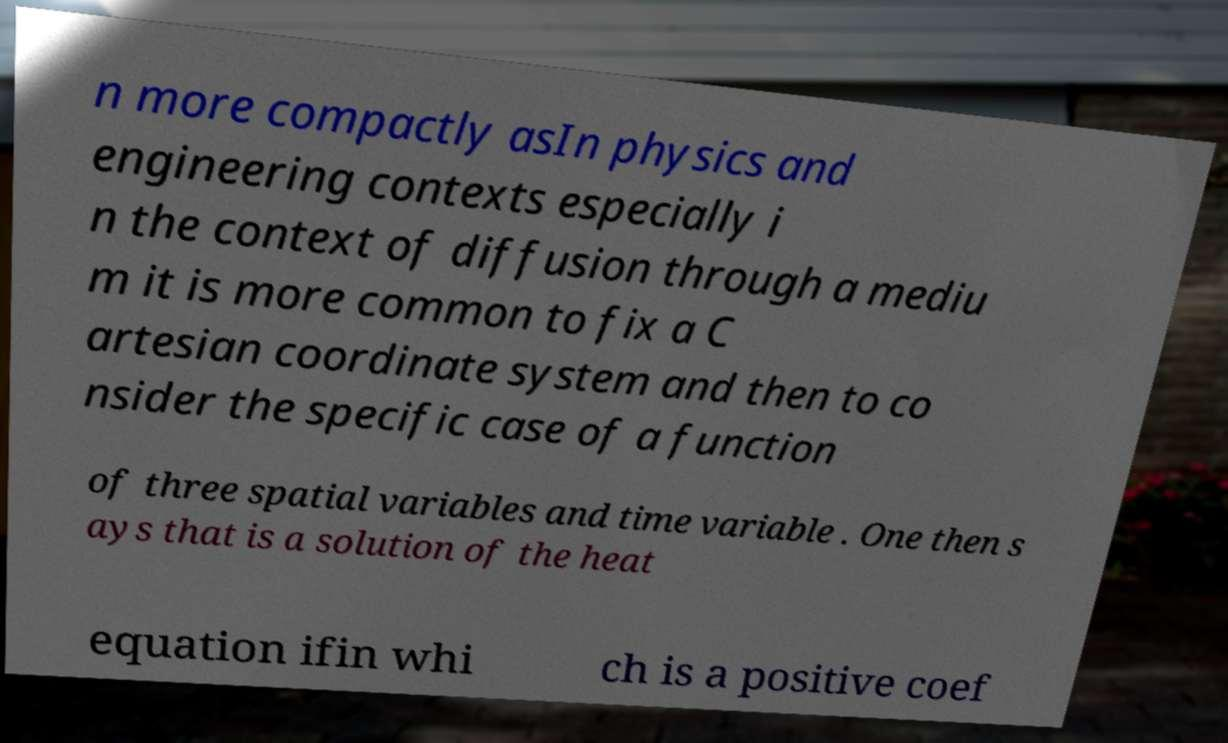There's text embedded in this image that I need extracted. Can you transcribe it verbatim? n more compactly asIn physics and engineering contexts especially i n the context of diffusion through a mediu m it is more common to fix a C artesian coordinate system and then to co nsider the specific case of a function of three spatial variables and time variable . One then s ays that is a solution of the heat equation ifin whi ch is a positive coef 